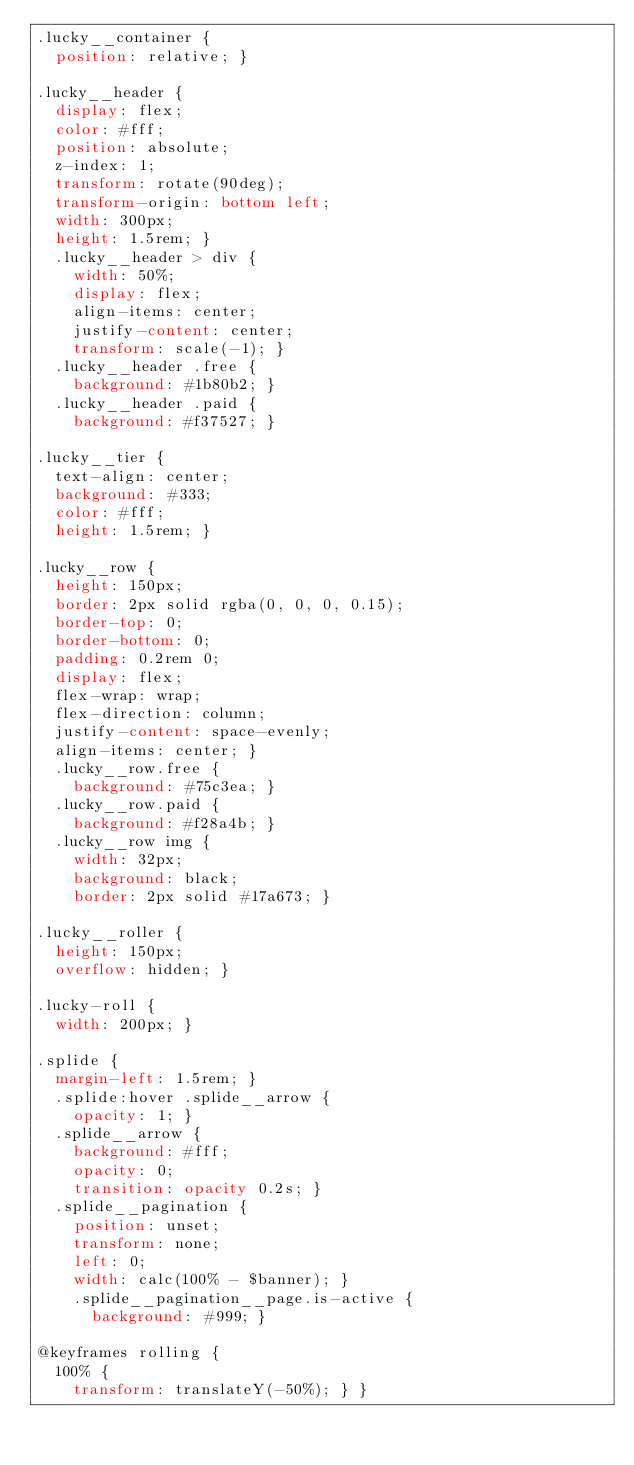<code> <loc_0><loc_0><loc_500><loc_500><_CSS_>.lucky__container {
  position: relative; }

.lucky__header {
  display: flex;
  color: #fff;
  position: absolute;
  z-index: 1;
  transform: rotate(90deg);
  transform-origin: bottom left;
  width: 300px;
  height: 1.5rem; }
  .lucky__header > div {
    width: 50%;
    display: flex;
    align-items: center;
    justify-content: center;
    transform: scale(-1); }
  .lucky__header .free {
    background: #1b80b2; }
  .lucky__header .paid {
    background: #f37527; }

.lucky__tier {
  text-align: center;
  background: #333;
  color: #fff;
  height: 1.5rem; }

.lucky__row {
  height: 150px;
  border: 2px solid rgba(0, 0, 0, 0.15);
  border-top: 0;
  border-bottom: 0;
  padding: 0.2rem 0;
  display: flex;
  flex-wrap: wrap;
  flex-direction: column;
  justify-content: space-evenly;
  align-items: center; }
  .lucky__row.free {
    background: #75c3ea; }
  .lucky__row.paid {
    background: #f28a4b; }
  .lucky__row img {
    width: 32px;
    background: black;
    border: 2px solid #17a673; }

.lucky__roller {
  height: 150px;
  overflow: hidden; }

.lucky-roll {
  width: 200px; }

.splide {
  margin-left: 1.5rem; }
  .splide:hover .splide__arrow {
    opacity: 1; }
  .splide__arrow {
    background: #fff;
    opacity: 0;
    transition: opacity 0.2s; }
  .splide__pagination {
    position: unset;
    transform: none;
    left: 0;
    width: calc(100% - $banner); }
    .splide__pagination__page.is-active {
      background: #999; }

@keyframes rolling {
  100% {
    transform: translateY(-50%); } }
</code> 